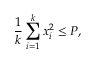Convert formula to latex. <formula><loc_0><loc_0><loc_500><loc_500>{ \frac { 1 } { k } } \sum _ { i = 1 } ^ { k } x _ { i } ^ { 2 } \leq P ,</formula> 